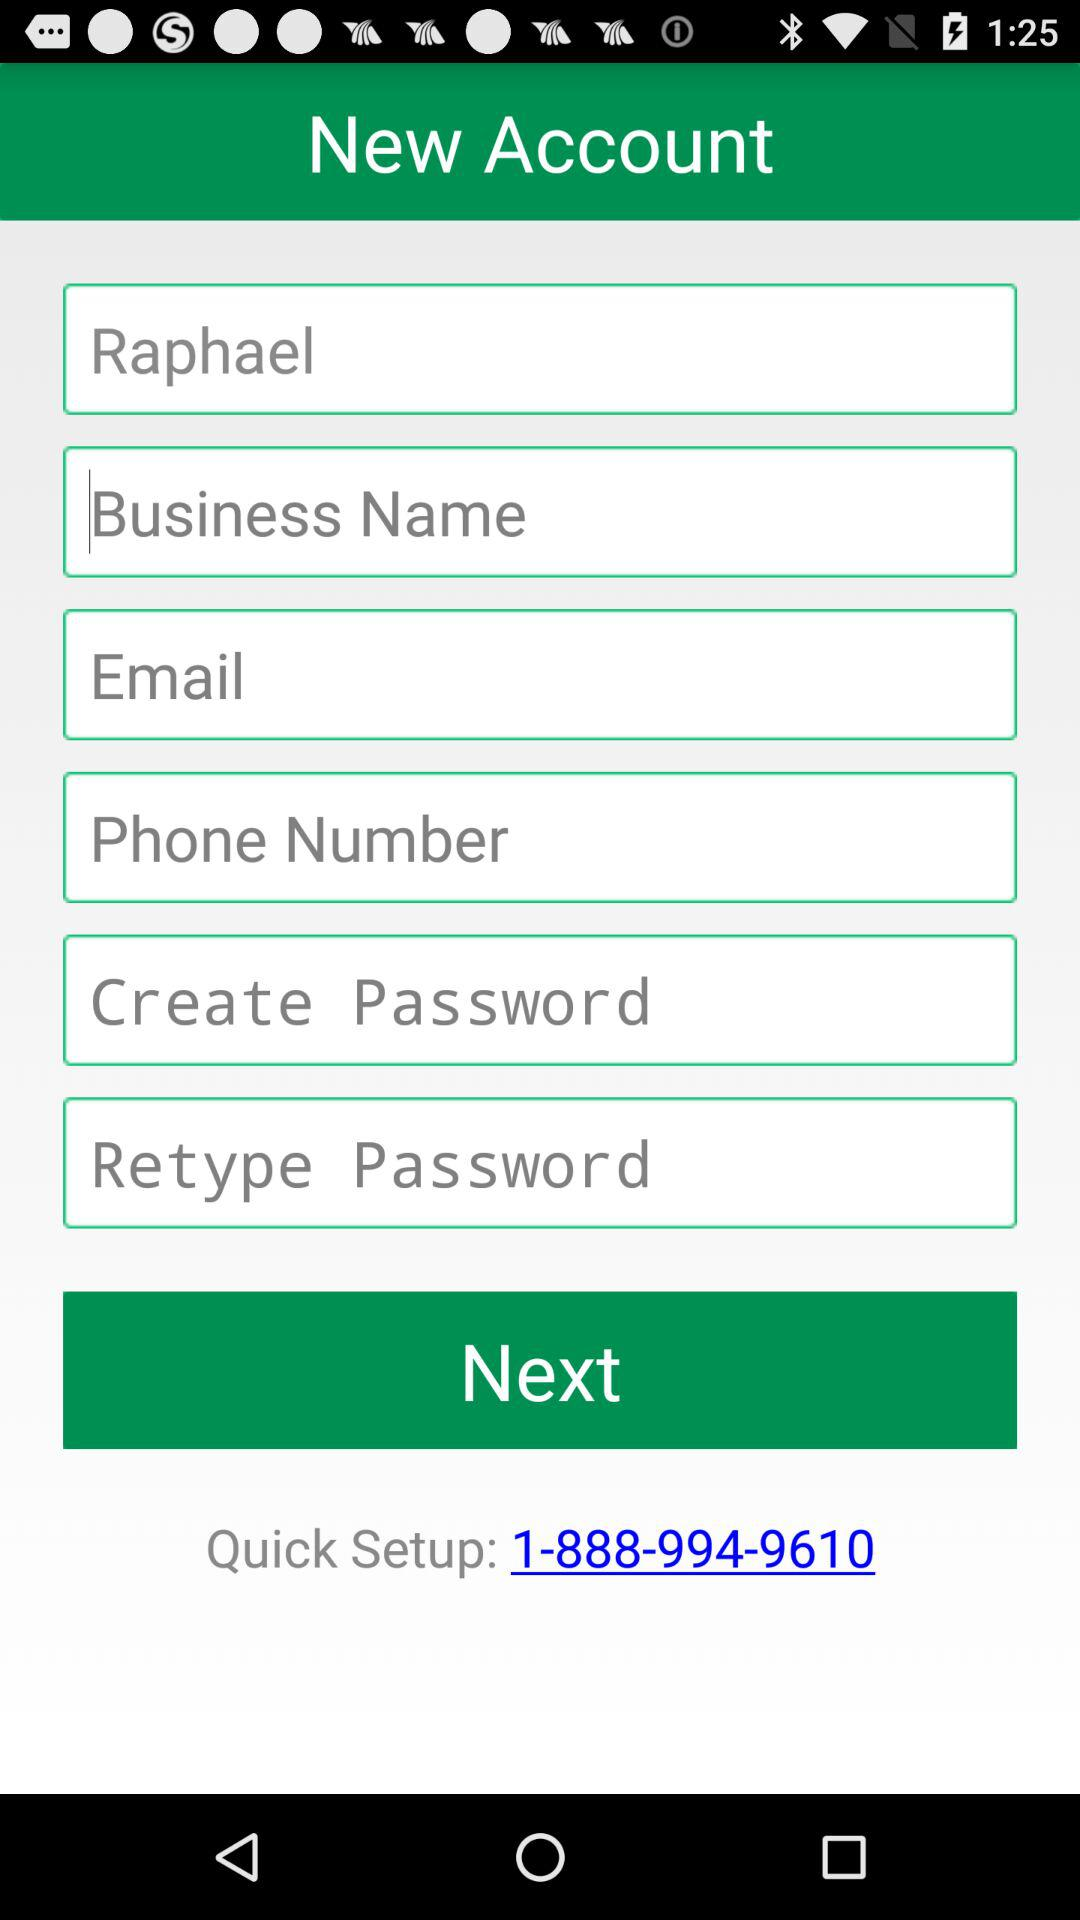What is the quick setup number? The quick setup number is 1-888-994-9610. 